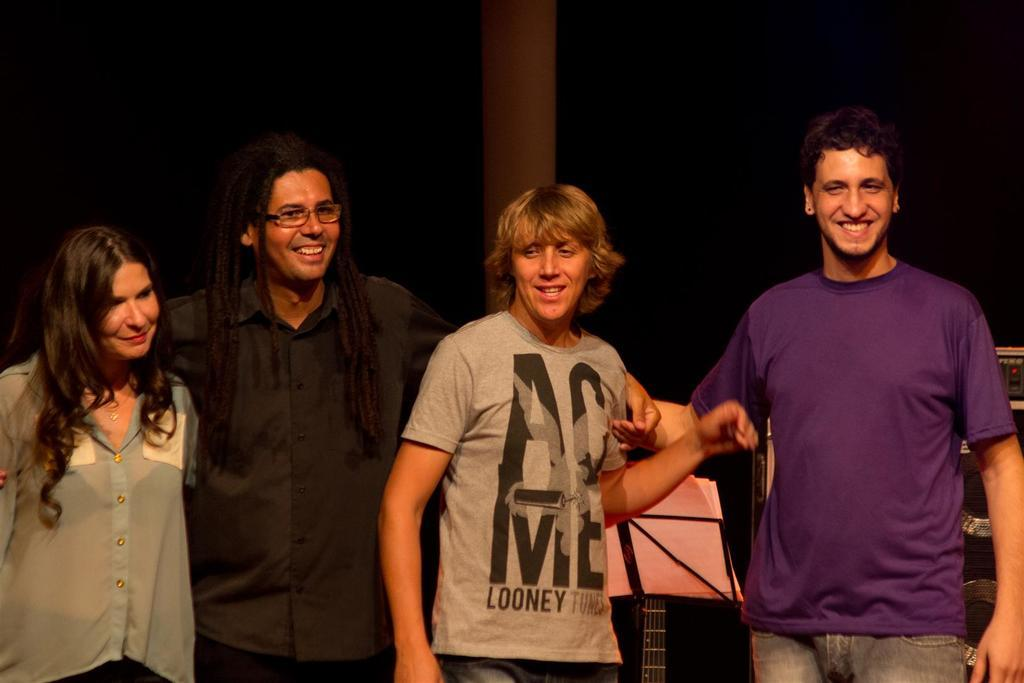What is happening in the center of the image? There are people standing in the center of the image. What can be seen in the background of the image? There is a pillar in the background of the image. What type of pan is being used by the people in the image? There is no pan present in the image; it only shows people standing and a pillar in the background. 